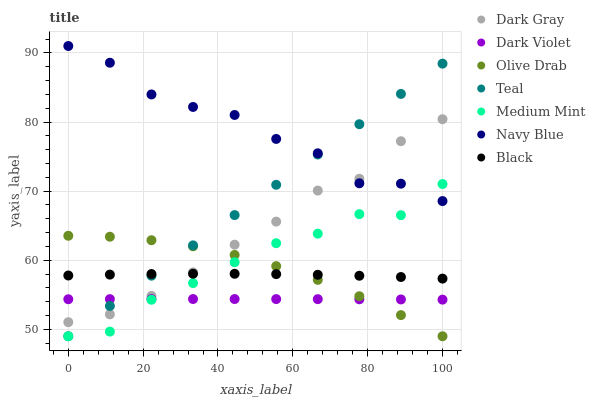Does Dark Violet have the minimum area under the curve?
Answer yes or no. Yes. Does Navy Blue have the maximum area under the curve?
Answer yes or no. Yes. Does Navy Blue have the minimum area under the curve?
Answer yes or no. No. Does Dark Violet have the maximum area under the curve?
Answer yes or no. No. Is Teal the smoothest?
Answer yes or no. Yes. Is Navy Blue the roughest?
Answer yes or no. Yes. Is Dark Violet the smoothest?
Answer yes or no. No. Is Dark Violet the roughest?
Answer yes or no. No. Does Medium Mint have the lowest value?
Answer yes or no. Yes. Does Dark Violet have the lowest value?
Answer yes or no. No. Does Navy Blue have the highest value?
Answer yes or no. Yes. Does Dark Violet have the highest value?
Answer yes or no. No. Is Dark Violet less than Navy Blue?
Answer yes or no. Yes. Is Black greater than Dark Violet?
Answer yes or no. Yes. Does Dark Gray intersect Teal?
Answer yes or no. Yes. Is Dark Gray less than Teal?
Answer yes or no. No. Is Dark Gray greater than Teal?
Answer yes or no. No. Does Dark Violet intersect Navy Blue?
Answer yes or no. No. 